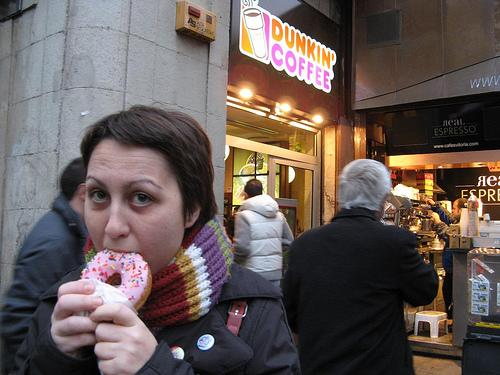What is the woman eating the donut wearing? scarf 